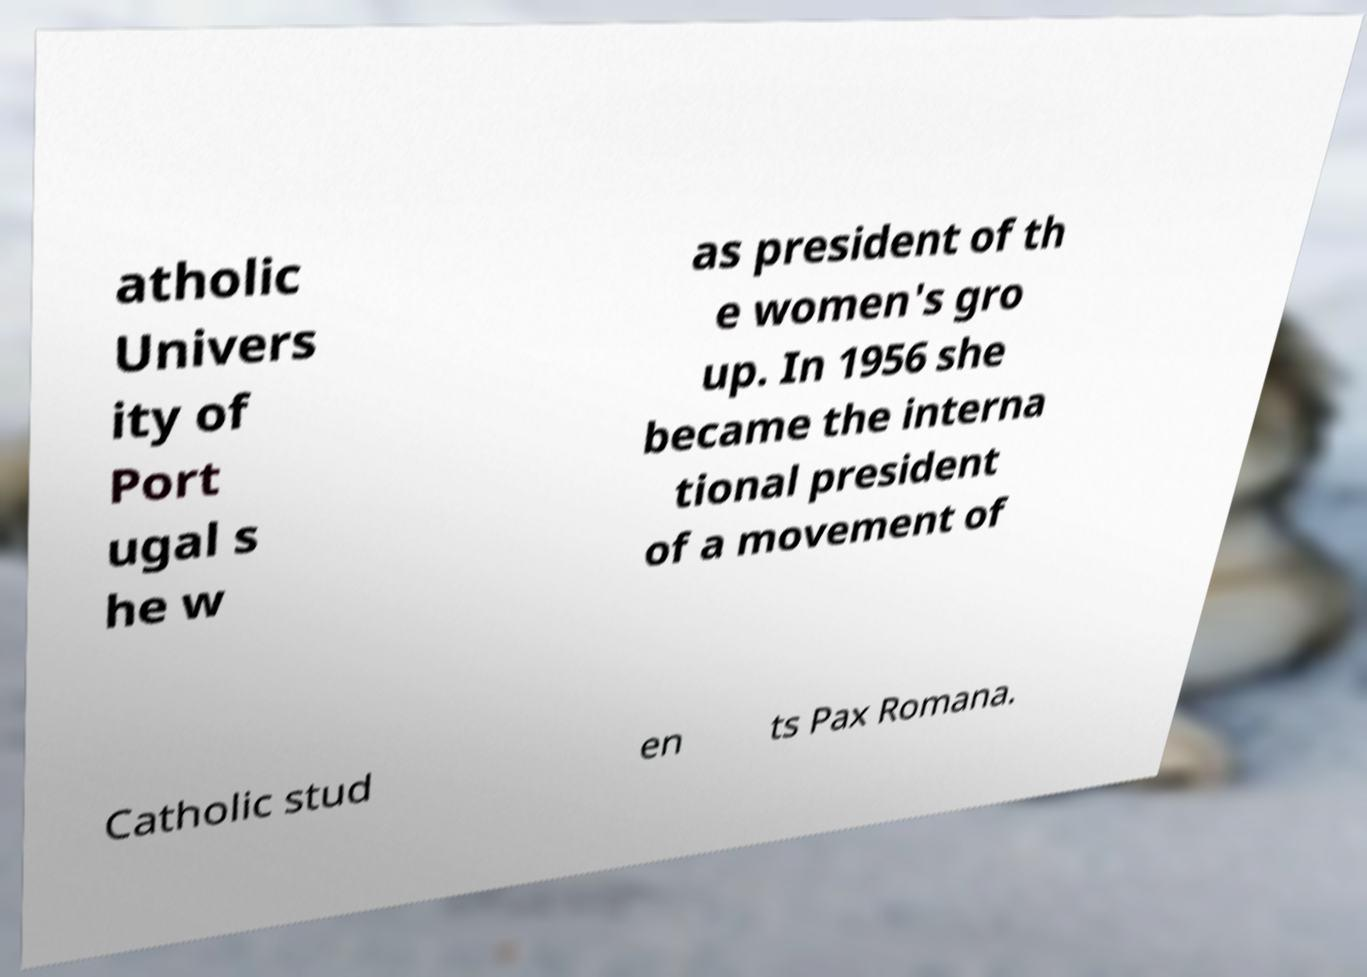Please identify and transcribe the text found in this image. atholic Univers ity of Port ugal s he w as president of th e women's gro up. In 1956 she became the interna tional president of a movement of Catholic stud en ts Pax Romana. 